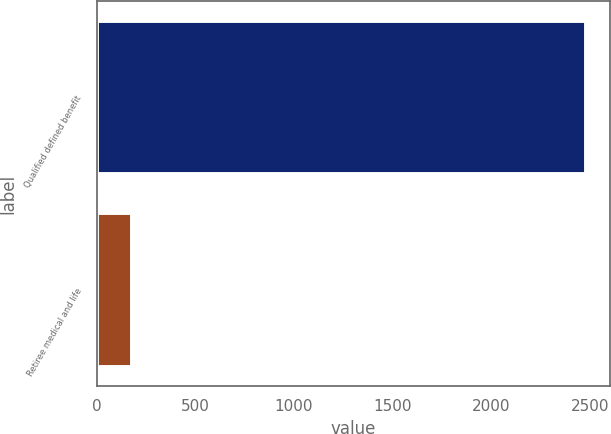Convert chart to OTSL. <chart><loc_0><loc_0><loc_500><loc_500><bar_chart><fcel>Qualified defined benefit<fcel>Retiree medical and life<nl><fcel>2480<fcel>180<nl></chart> 